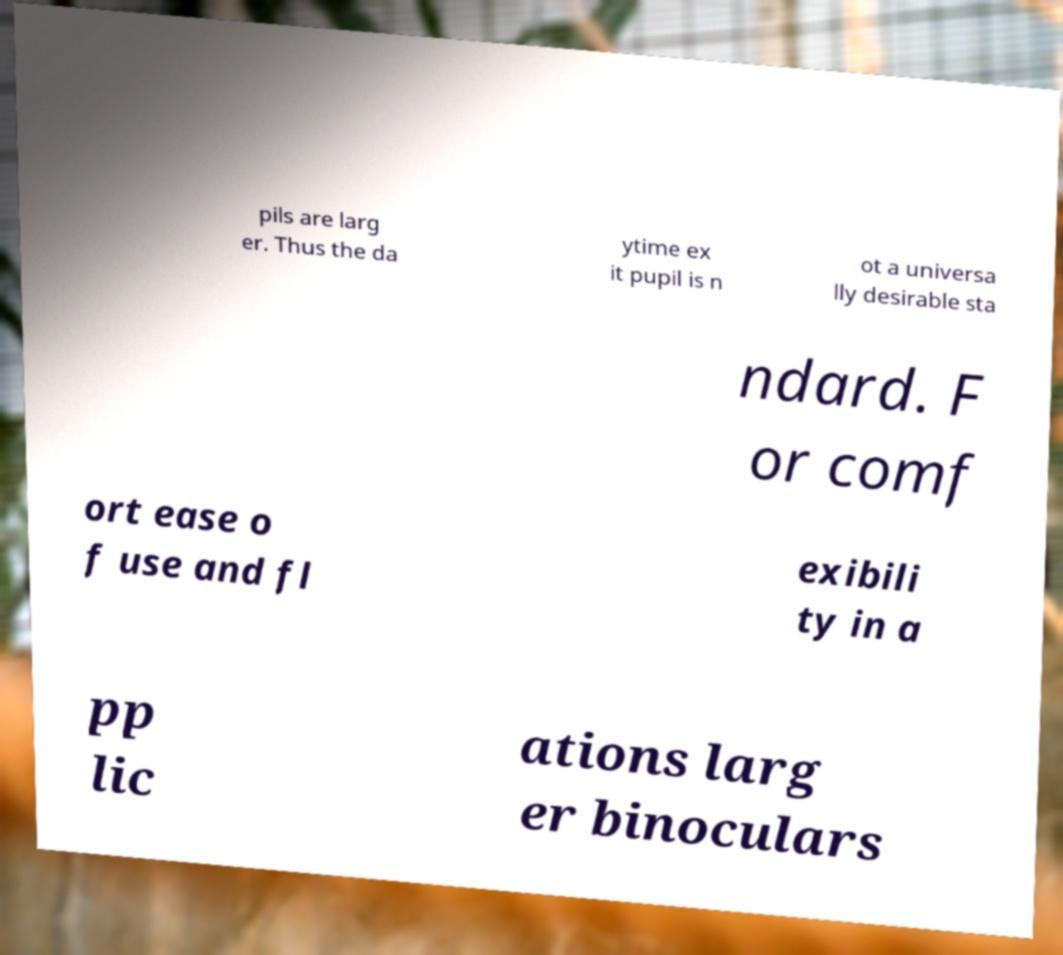Can you read and provide the text displayed in the image?This photo seems to have some interesting text. Can you extract and type it out for me? pils are larg er. Thus the da ytime ex it pupil is n ot a universa lly desirable sta ndard. F or comf ort ease o f use and fl exibili ty in a pp lic ations larg er binoculars 